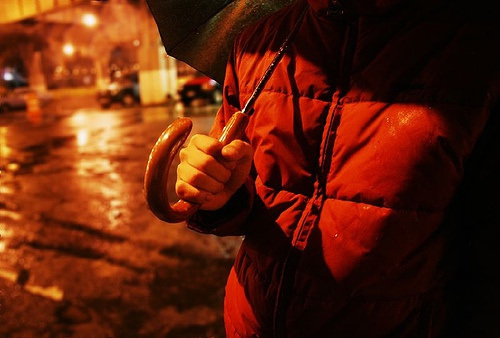Describe the objects in this image and their specific colors. I can see people in orange, black, red, and maroon tones, umbrella in orange, black, maroon, brown, and red tones, umbrella in orange, black, maroon, and brown tones, car in orange, black, maroon, brown, and red tones, and car in orange, maroon, black, and brown tones in this image. 